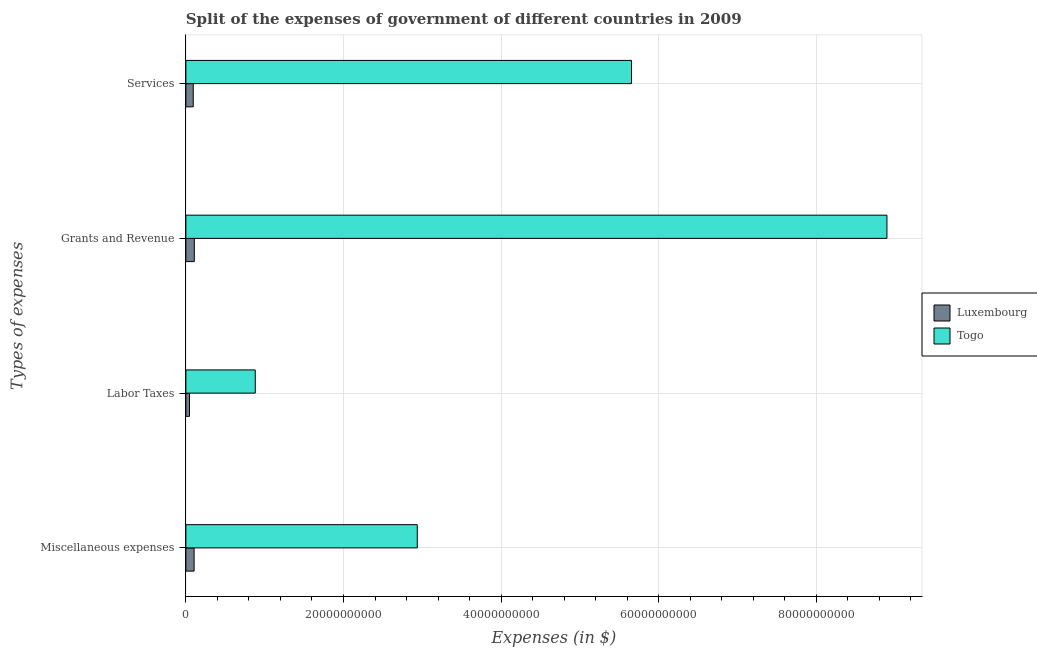How many bars are there on the 1st tick from the top?
Offer a very short reply. 2. What is the label of the 3rd group of bars from the top?
Your answer should be very brief. Labor Taxes. What is the amount spent on grants and revenue in Luxembourg?
Make the answer very short. 1.07e+09. Across all countries, what is the maximum amount spent on services?
Offer a very short reply. 5.65e+1. Across all countries, what is the minimum amount spent on labor taxes?
Provide a short and direct response. 4.58e+08. In which country was the amount spent on services maximum?
Offer a terse response. Togo. In which country was the amount spent on labor taxes minimum?
Provide a short and direct response. Luxembourg. What is the total amount spent on services in the graph?
Your answer should be very brief. 5.75e+1. What is the difference between the amount spent on miscellaneous expenses in Togo and that in Luxembourg?
Offer a terse response. 2.83e+1. What is the difference between the amount spent on miscellaneous expenses in Luxembourg and the amount spent on services in Togo?
Offer a terse response. -5.55e+1. What is the average amount spent on labor taxes per country?
Give a very brief answer. 4.63e+09. What is the difference between the amount spent on miscellaneous expenses and amount spent on grants and revenue in Luxembourg?
Your answer should be very brief. -2.60e+07. What is the ratio of the amount spent on grants and revenue in Togo to that in Luxembourg?
Offer a very short reply. 83.1. Is the amount spent on labor taxes in Togo less than that in Luxembourg?
Your response must be concise. No. Is the difference between the amount spent on miscellaneous expenses in Togo and Luxembourg greater than the difference between the amount spent on grants and revenue in Togo and Luxembourg?
Provide a short and direct response. No. What is the difference between the highest and the second highest amount spent on miscellaneous expenses?
Ensure brevity in your answer.  2.83e+1. What is the difference between the highest and the lowest amount spent on services?
Offer a terse response. 5.56e+1. Is it the case that in every country, the sum of the amount spent on grants and revenue and amount spent on services is greater than the sum of amount spent on miscellaneous expenses and amount spent on labor taxes?
Your answer should be very brief. No. What does the 1st bar from the top in Grants and Revenue represents?
Your answer should be very brief. Togo. What does the 2nd bar from the bottom in Labor Taxes represents?
Your answer should be compact. Togo. Is it the case that in every country, the sum of the amount spent on miscellaneous expenses and amount spent on labor taxes is greater than the amount spent on grants and revenue?
Provide a succinct answer. No. Are all the bars in the graph horizontal?
Offer a terse response. Yes. Does the graph contain any zero values?
Offer a very short reply. No. Does the graph contain grids?
Your response must be concise. Yes. Where does the legend appear in the graph?
Your response must be concise. Center right. How many legend labels are there?
Provide a succinct answer. 2. How are the legend labels stacked?
Provide a succinct answer. Vertical. What is the title of the graph?
Offer a very short reply. Split of the expenses of government of different countries in 2009. What is the label or title of the X-axis?
Provide a succinct answer. Expenses (in $). What is the label or title of the Y-axis?
Offer a very short reply. Types of expenses. What is the Expenses (in $) in Luxembourg in Miscellaneous expenses?
Your answer should be very brief. 1.04e+09. What is the Expenses (in $) of Togo in Miscellaneous expenses?
Keep it short and to the point. 2.94e+1. What is the Expenses (in $) in Luxembourg in Labor Taxes?
Offer a terse response. 4.58e+08. What is the Expenses (in $) in Togo in Labor Taxes?
Provide a succinct answer. 8.80e+09. What is the Expenses (in $) of Luxembourg in Grants and Revenue?
Your answer should be compact. 1.07e+09. What is the Expenses (in $) of Togo in Grants and Revenue?
Your response must be concise. 8.90e+1. What is the Expenses (in $) of Luxembourg in Services?
Your answer should be compact. 9.36e+08. What is the Expenses (in $) of Togo in Services?
Your answer should be compact. 5.65e+1. Across all Types of expenses, what is the maximum Expenses (in $) of Luxembourg?
Your answer should be compact. 1.07e+09. Across all Types of expenses, what is the maximum Expenses (in $) of Togo?
Offer a very short reply. 8.90e+1. Across all Types of expenses, what is the minimum Expenses (in $) of Luxembourg?
Give a very brief answer. 4.58e+08. Across all Types of expenses, what is the minimum Expenses (in $) of Togo?
Provide a succinct answer. 8.80e+09. What is the total Expenses (in $) of Luxembourg in the graph?
Offer a very short reply. 3.51e+09. What is the total Expenses (in $) of Togo in the graph?
Provide a succinct answer. 1.84e+11. What is the difference between the Expenses (in $) of Luxembourg in Miscellaneous expenses and that in Labor Taxes?
Your response must be concise. 5.87e+08. What is the difference between the Expenses (in $) of Togo in Miscellaneous expenses and that in Labor Taxes?
Your answer should be compact. 2.06e+1. What is the difference between the Expenses (in $) in Luxembourg in Miscellaneous expenses and that in Grants and Revenue?
Offer a terse response. -2.60e+07. What is the difference between the Expenses (in $) of Togo in Miscellaneous expenses and that in Grants and Revenue?
Keep it short and to the point. -5.96e+1. What is the difference between the Expenses (in $) of Luxembourg in Miscellaneous expenses and that in Services?
Offer a terse response. 1.08e+08. What is the difference between the Expenses (in $) of Togo in Miscellaneous expenses and that in Services?
Your answer should be compact. -2.72e+1. What is the difference between the Expenses (in $) of Luxembourg in Labor Taxes and that in Grants and Revenue?
Your response must be concise. -6.13e+08. What is the difference between the Expenses (in $) of Togo in Labor Taxes and that in Grants and Revenue?
Offer a terse response. -8.01e+1. What is the difference between the Expenses (in $) of Luxembourg in Labor Taxes and that in Services?
Provide a short and direct response. -4.78e+08. What is the difference between the Expenses (in $) in Togo in Labor Taxes and that in Services?
Your answer should be compact. -4.77e+1. What is the difference between the Expenses (in $) in Luxembourg in Grants and Revenue and that in Services?
Ensure brevity in your answer.  1.34e+08. What is the difference between the Expenses (in $) in Togo in Grants and Revenue and that in Services?
Make the answer very short. 3.24e+1. What is the difference between the Expenses (in $) of Luxembourg in Miscellaneous expenses and the Expenses (in $) of Togo in Labor Taxes?
Provide a short and direct response. -7.76e+09. What is the difference between the Expenses (in $) of Luxembourg in Miscellaneous expenses and the Expenses (in $) of Togo in Grants and Revenue?
Offer a terse response. -8.79e+1. What is the difference between the Expenses (in $) in Luxembourg in Miscellaneous expenses and the Expenses (in $) in Togo in Services?
Keep it short and to the point. -5.55e+1. What is the difference between the Expenses (in $) in Luxembourg in Labor Taxes and the Expenses (in $) in Togo in Grants and Revenue?
Your answer should be compact. -8.85e+1. What is the difference between the Expenses (in $) in Luxembourg in Labor Taxes and the Expenses (in $) in Togo in Services?
Make the answer very short. -5.61e+1. What is the difference between the Expenses (in $) in Luxembourg in Grants and Revenue and the Expenses (in $) in Togo in Services?
Make the answer very short. -5.55e+1. What is the average Expenses (in $) of Luxembourg per Types of expenses?
Your response must be concise. 8.77e+08. What is the average Expenses (in $) of Togo per Types of expenses?
Make the answer very short. 4.59e+1. What is the difference between the Expenses (in $) in Luxembourg and Expenses (in $) in Togo in Miscellaneous expenses?
Your answer should be compact. -2.83e+1. What is the difference between the Expenses (in $) of Luxembourg and Expenses (in $) of Togo in Labor Taxes?
Give a very brief answer. -8.35e+09. What is the difference between the Expenses (in $) in Luxembourg and Expenses (in $) in Togo in Grants and Revenue?
Your response must be concise. -8.79e+1. What is the difference between the Expenses (in $) in Luxembourg and Expenses (in $) in Togo in Services?
Offer a terse response. -5.56e+1. What is the ratio of the Expenses (in $) in Luxembourg in Miscellaneous expenses to that in Labor Taxes?
Make the answer very short. 2.28. What is the ratio of the Expenses (in $) in Togo in Miscellaneous expenses to that in Labor Taxes?
Your response must be concise. 3.33. What is the ratio of the Expenses (in $) in Luxembourg in Miscellaneous expenses to that in Grants and Revenue?
Your answer should be very brief. 0.98. What is the ratio of the Expenses (in $) of Togo in Miscellaneous expenses to that in Grants and Revenue?
Your response must be concise. 0.33. What is the ratio of the Expenses (in $) of Luxembourg in Miscellaneous expenses to that in Services?
Make the answer very short. 1.12. What is the ratio of the Expenses (in $) of Togo in Miscellaneous expenses to that in Services?
Provide a succinct answer. 0.52. What is the ratio of the Expenses (in $) of Luxembourg in Labor Taxes to that in Grants and Revenue?
Offer a terse response. 0.43. What is the ratio of the Expenses (in $) in Togo in Labor Taxes to that in Grants and Revenue?
Your response must be concise. 0.1. What is the ratio of the Expenses (in $) of Luxembourg in Labor Taxes to that in Services?
Give a very brief answer. 0.49. What is the ratio of the Expenses (in $) of Togo in Labor Taxes to that in Services?
Provide a succinct answer. 0.16. What is the ratio of the Expenses (in $) in Luxembourg in Grants and Revenue to that in Services?
Provide a short and direct response. 1.14. What is the ratio of the Expenses (in $) of Togo in Grants and Revenue to that in Services?
Offer a very short reply. 1.57. What is the difference between the highest and the second highest Expenses (in $) in Luxembourg?
Ensure brevity in your answer.  2.60e+07. What is the difference between the highest and the second highest Expenses (in $) in Togo?
Your response must be concise. 3.24e+1. What is the difference between the highest and the lowest Expenses (in $) of Luxembourg?
Offer a very short reply. 6.13e+08. What is the difference between the highest and the lowest Expenses (in $) in Togo?
Make the answer very short. 8.01e+1. 